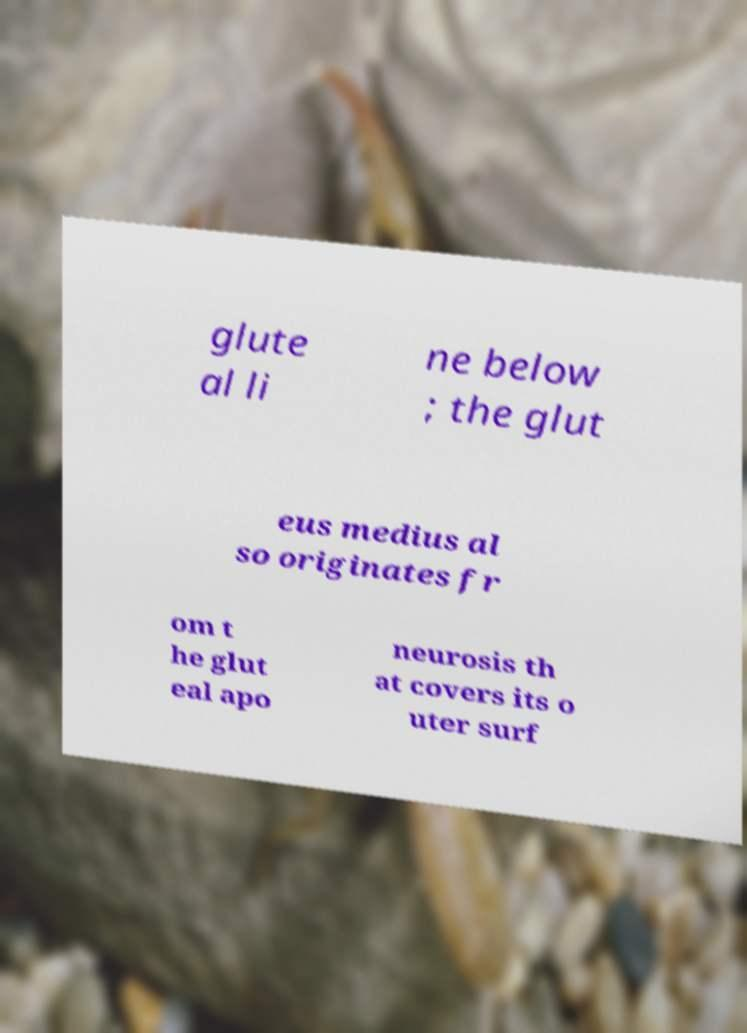Could you extract and type out the text from this image? glute al li ne below ; the glut eus medius al so originates fr om t he glut eal apo neurosis th at covers its o uter surf 